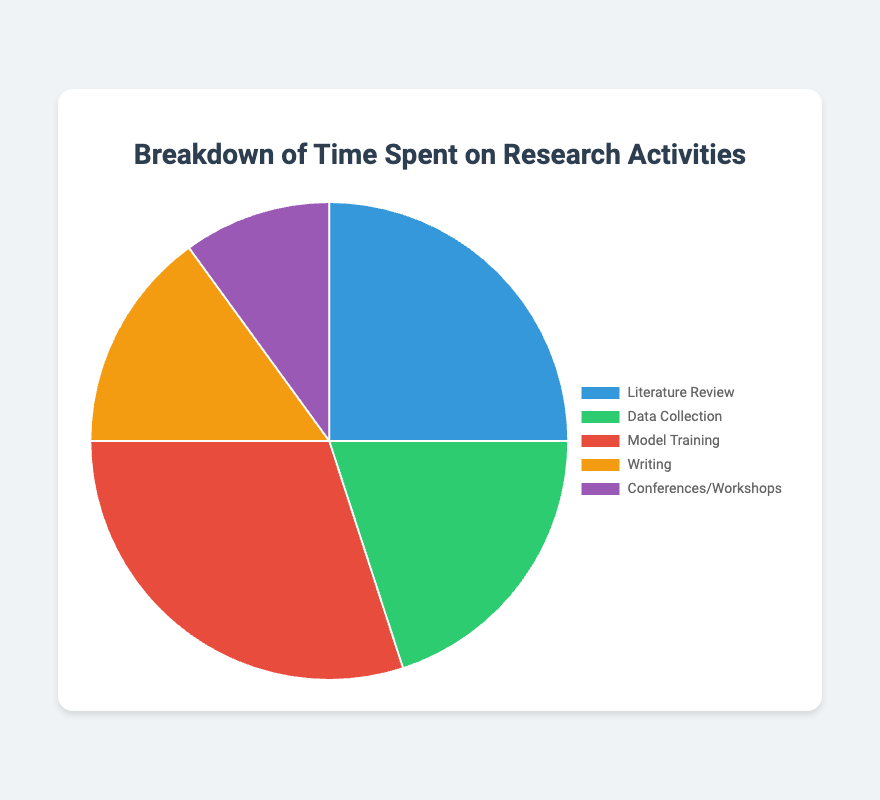Which activity consumes the most time? The activity with the highest percentage on the pie chart is Model Training with 30%.
Answer: Model Training Which activity consumes the least time? The activity with the lowest percentage on the pie chart is Conferences/Workshops with 10%.
Answer: Conferences/Workshops How much more time is spent on Literature Review compared to Writing? Time spent on Literature Review is 25%, and time spent on Writing is 15%. The difference is 25% - 15% = 10%.
Answer: 10% What is the total percentage of time spent on Literature Review and Model Training combined? Time spent on Literature Review is 25%, and time spent on Model Training is 30%. The total is 25% + 30% = 55%.
Answer: 55% Which two activities combined make up 50% of the total time? Data Collection takes 20%, and Writing takes 15%. Together they sum to 20% + 15% = 35%. Checking another combination, Data Collection (20%) and Conferences/Workshops (10%) makes 30%. Finally, Writing (15%) and Conferences/Workshops (10%) make 25%. Thus, no two activities combine to exactly 50%.
Answer: None Which activity's time is half that of Model Training? Model Training takes 30%, so half would be 30% / 2 = 15%. Checking the pie chart, Writing corresponds to 15%.
Answer: Writing Is more time spent on Data Collection or Literature Review? Time spent on Data Collection is 20%, whereas time spent on Literature Review is 25%. Comparing these values, 25% > 20%.
Answer: Literature Review What percentage more is spent on Model Training compared to Conferences/Workshops? Time spent on Model Training is 30%, while time spent on Conferences/Workshops is 10%. The difference is 30% - 10% = 20%.
Answer: 20% What are the colors used to represent Model Training and Literature Review? The pie chart shows Model Training in the color red and Literature Review in blue.
Answer: Red and Blue 